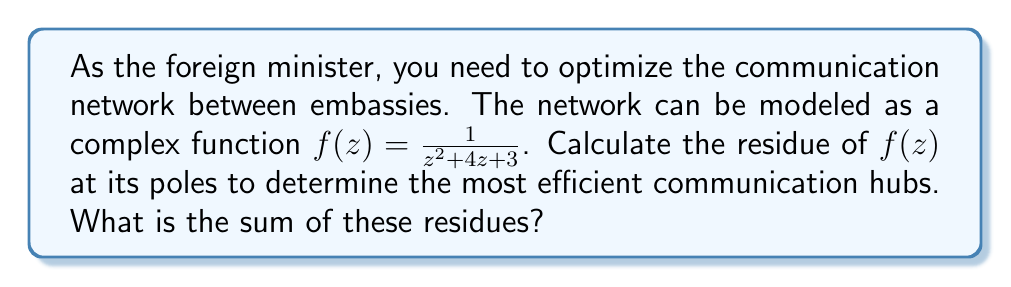Give your solution to this math problem. To solve this problem, we need to follow these steps:

1. Find the poles of the function $f(z) = \frac{1}{z^2 + 4z + 3}$
2. Determine the order of each pole
3. Calculate the residue at each pole
4. Sum the residues

Step 1: Finding the poles
The poles are the roots of the denominator: $z^2 + 4z + 3 = 0$
Using the quadratic formula: $z = \frac{-4 \pm \sqrt{16 - 12}}{2} = \frac{-4 \pm 2\sqrt{1}}{2}$
So, the poles are $z_1 = -1$ and $z_2 = -3$

Step 2: Determining the order of the poles
Both poles are simple (order 1) because they appear only once in the factored denominator.

Step 3: Calculating the residues
For a simple pole $a$, the residue is given by:
$$\text{Res}(f, a) = \lim_{z \to a} (z-a)f(z)$$

For $z_1 = -1$:
$$\begin{align*}
\text{Res}(f, -1) &= \lim_{z \to -1} (z+1)\frac{1}{z^2 + 4z + 3} \\
&= \lim_{z \to -1} \frac{z+1}{(z+1)(z+3)} \\
&= \frac{1}{-1+3} = \frac{1}{2}
\end{align*}$$

For $z_2 = -3$:
$$\begin{align*}
\text{Res}(f, -3) &= \lim_{z \to -3} (z+3)\frac{1}{z^2 + 4z + 3} \\
&= \lim_{z \to -3} \frac{z+3}{(z+1)(z+3)} \\
&= \frac{1}{-3+1} = -\frac{1}{2}
\end{align*}$$

Step 4: Summing the residues
Sum of residues $= \text{Res}(f, -1) + \text{Res}(f, -3) = \frac{1}{2} + (-\frac{1}{2}) = 0$
Answer: The sum of the residues is 0. 